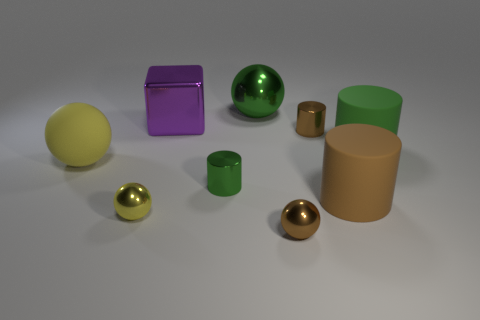There is a metal sphere that is the same color as the rubber sphere; what is its size? The metal sphere that shares the same earthy golden color as the rubber sphere appears to be small in size, with a diameter that looks to be less than a quarter of the size of the larger spheres in the image. 